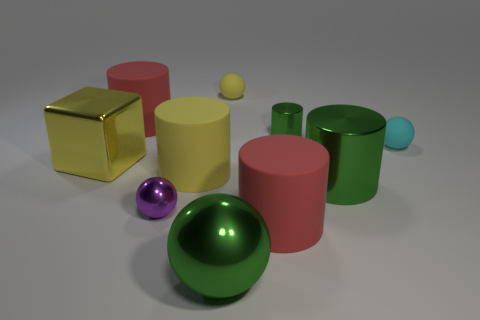Are there any other things that have the same shape as the yellow metal object?
Provide a succinct answer. No. The large metal object that is the same shape as the small cyan thing is what color?
Provide a short and direct response. Green. Is the shape of the purple shiny object the same as the small yellow matte thing?
Your answer should be very brief. Yes. Are there the same number of big red matte cylinders that are right of the big yellow matte object and yellow rubber spheres to the left of the big green metal ball?
Your response must be concise. No. The small sphere that is made of the same material as the small green cylinder is what color?
Provide a succinct answer. Purple. What number of large green objects have the same material as the large green sphere?
Your answer should be very brief. 1. Does the small shiny object behind the purple metal sphere have the same color as the large metal cylinder?
Offer a very short reply. Yes. How many big metal objects are the same shape as the small green object?
Your answer should be very brief. 1. Are there an equal number of green shiny things in front of the large yellow block and large brown metallic blocks?
Offer a very short reply. No. What is the color of the other shiny object that is the same size as the purple metal thing?
Your response must be concise. Green. 